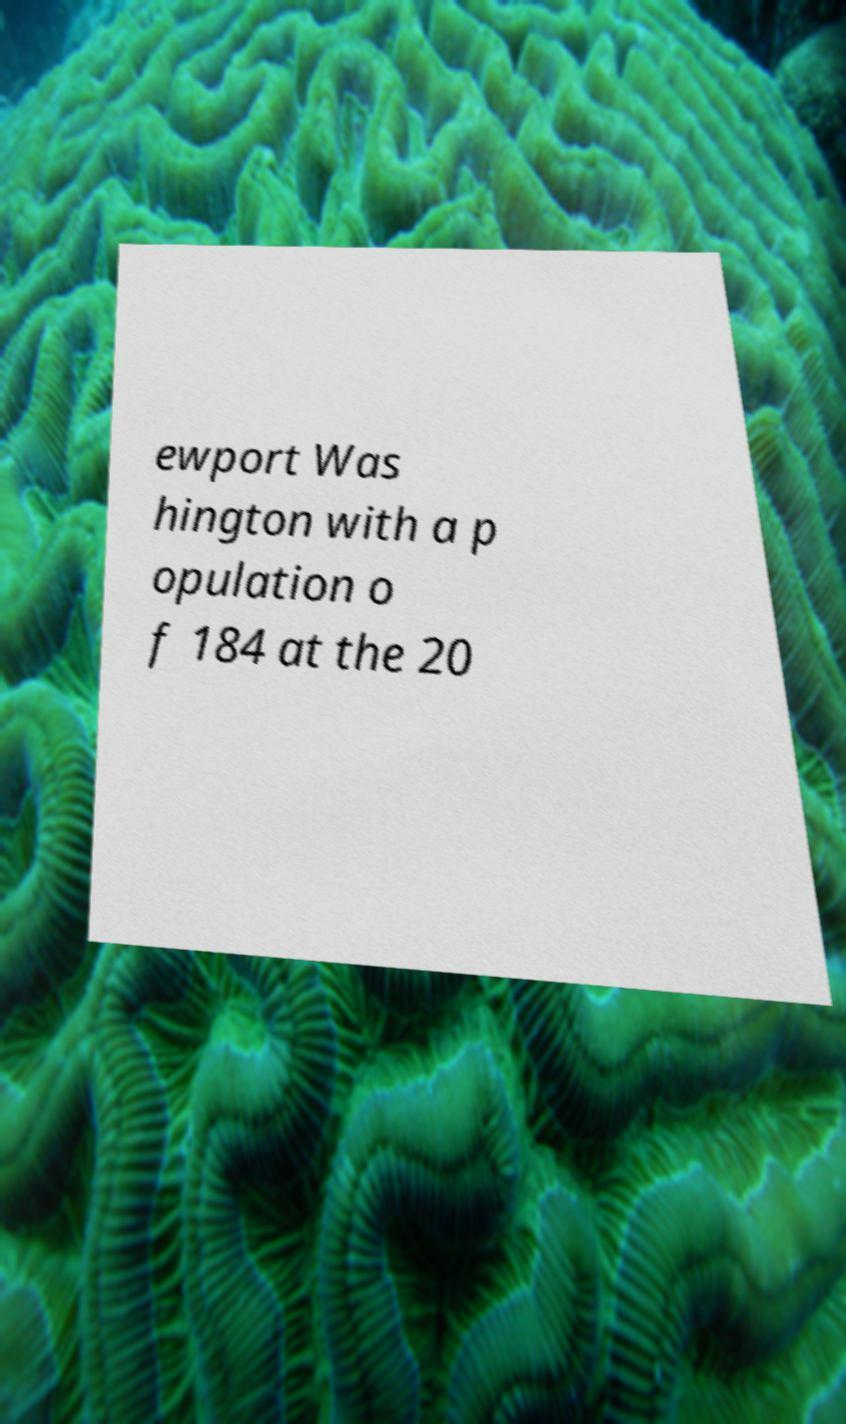Can you accurately transcribe the text from the provided image for me? ewport Was hington with a p opulation o f 184 at the 20 